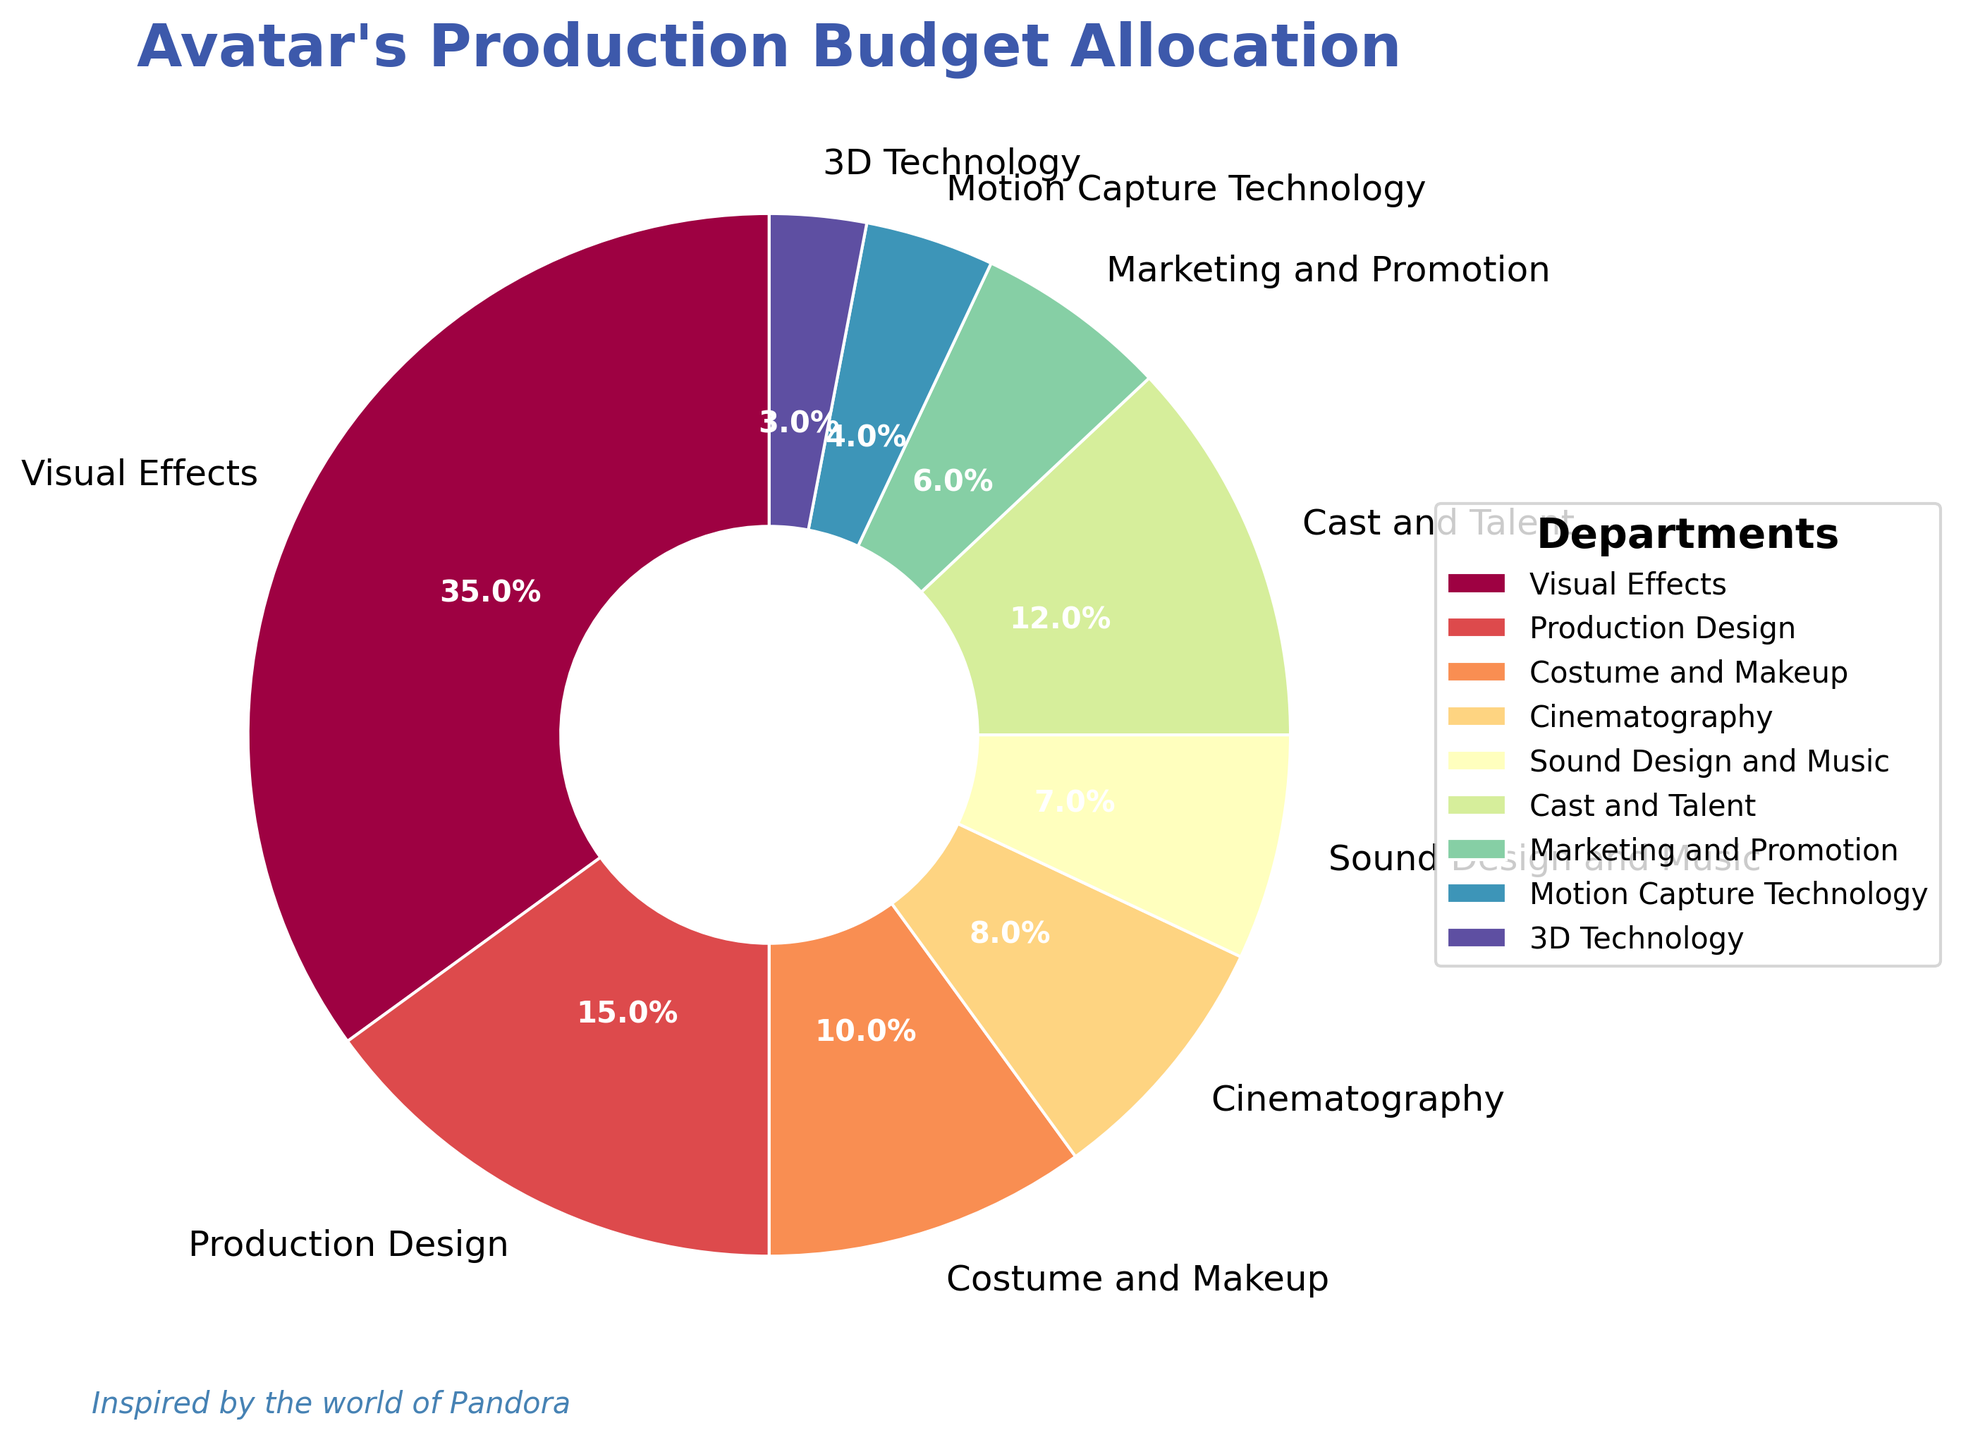Which department has the highest budget allocation? From the pie chart, the largest segment representing the department with the highest budget allocation is the one labeled "Visual Effects"
Answer: Visual Effects What is the total percentage allocation for Costume and Makeup and Cinematography combined? From the pie chart, the allocation for Costume and Makeup is 10%, and for Cinematography, it is 8%. Adding these together gives 10% + 8% = 18%
Answer: 18% Which department has a higher budget allocation: Cast and Talent or Sound Design and Music? From the pie chart, Cast and Talent has an allocation of 12%, whereas Sound Design and Music has an allocation of 7%. Therefore, Cast and Talent has a higher budget allocation
Answer: Cast and Talent How much more is allocated to Production Design than to 3D Technology? From the pie chart, Production Design has 15% allocated, and 3D Technology has 3%. The difference is 15% - 3% = 12%
Answer: 12% What is the ratio of the budget allocation between Marketing and Promotion and Motion Capture Technology? Marketing and Promotion has an allocation of 6%, and Motion Capture Technology has an allocation of 4%. The ratio is 6:4, which simplifies to 3:2
Answer: 3:2 If the budget allocation for Visual Effects was reduced by 5%, what would the new allocation percentage be? From the pie chart, Visual Effects is allocated 35%. Reducing this by 5% results in 35% - 5% = 30%
Answer: 30% What is the average budget allocation across all departments? Summing the allocations from the pie chart: 35 + 15 + 10 + 8 + 7 + 12 + 6 + 4 + 3 = 100%. There are 9 departments. The average allocation is 100% / 9 ≈ 11.11%
Answer: 11.11% Which department has the smallest budget allocation, and what is it? From the pie chart, the smallest segment representing the department with the smallest budget allocation is labeled "3D Technology", which has an allocation of 3%
Answer: 3D Technology, 3% 